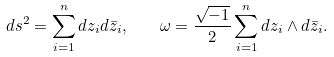Convert formula to latex. <formula><loc_0><loc_0><loc_500><loc_500>d s ^ { 2 } = \sum _ { i = 1 } ^ { n } d z _ { i } d \bar { z } _ { i } , \quad \omega = \frac { \sqrt { - 1 } } { 2 } \sum _ { i = 1 } ^ { n } d z _ { i } \wedge d \bar { z } _ { i } .</formula> 